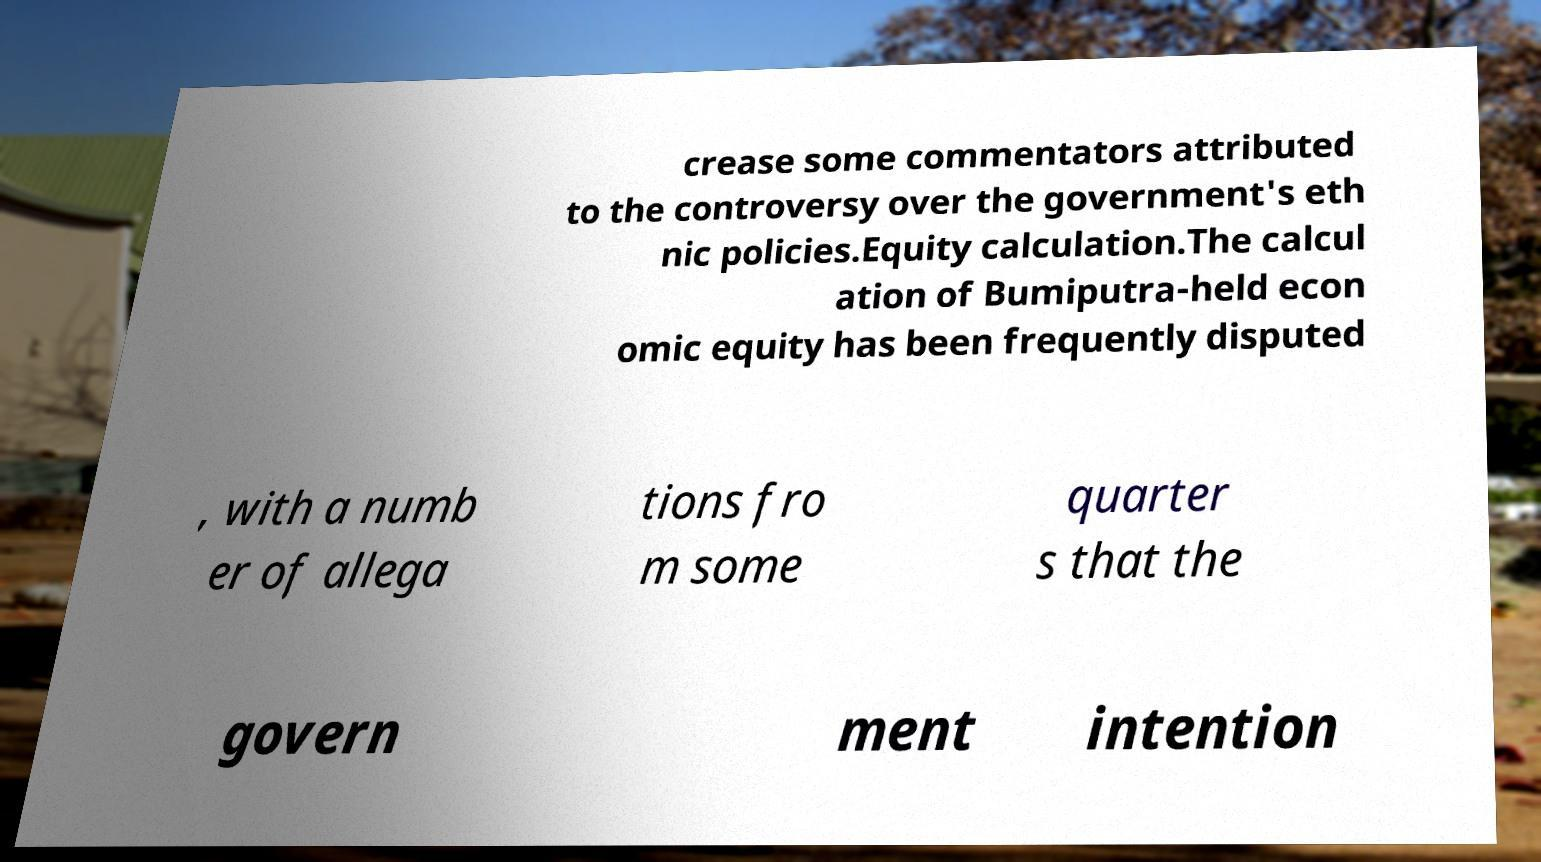For documentation purposes, I need the text within this image transcribed. Could you provide that? crease some commentators attributed to the controversy over the government's eth nic policies.Equity calculation.The calcul ation of Bumiputra-held econ omic equity has been frequently disputed , with a numb er of allega tions fro m some quarter s that the govern ment intention 